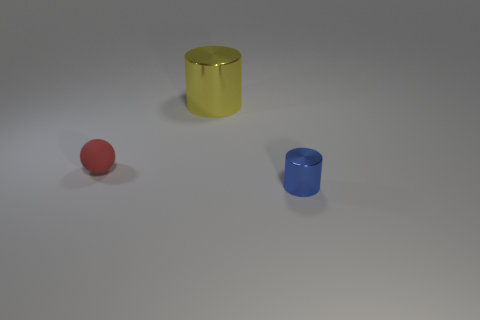Subtract all balls. How many objects are left? 2 Add 2 tiny green metal objects. How many objects exist? 5 Add 2 blue cylinders. How many blue cylinders are left? 3 Add 2 small red balls. How many small red balls exist? 3 Subtract all yellow cylinders. How many cylinders are left? 1 Subtract 0 yellow spheres. How many objects are left? 3 Subtract 1 cylinders. How many cylinders are left? 1 Subtract all gray balls. Subtract all blue cylinders. How many balls are left? 1 Subtract all cyan spheres. How many red cylinders are left? 0 Subtract all blue cylinders. Subtract all red things. How many objects are left? 1 